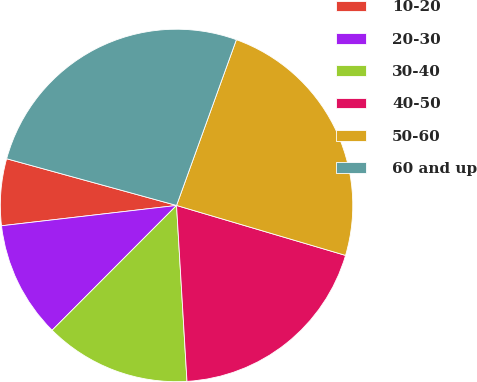Convert chart. <chart><loc_0><loc_0><loc_500><loc_500><pie_chart><fcel>10-20<fcel>20-30<fcel>30-40<fcel>40-50<fcel>50-60<fcel>60 and up<nl><fcel>6.11%<fcel>10.68%<fcel>13.42%<fcel>19.48%<fcel>24.06%<fcel>26.24%<nl></chart> 